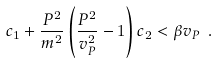Convert formula to latex. <formula><loc_0><loc_0><loc_500><loc_500>c _ { 1 } + \frac { P ^ { 2 } } { m ^ { 2 } } \left ( \frac { P ^ { 2 } } { v _ { P } ^ { 2 } } - 1 \right ) c _ { 2 } < \beta v _ { P } \ .</formula> 